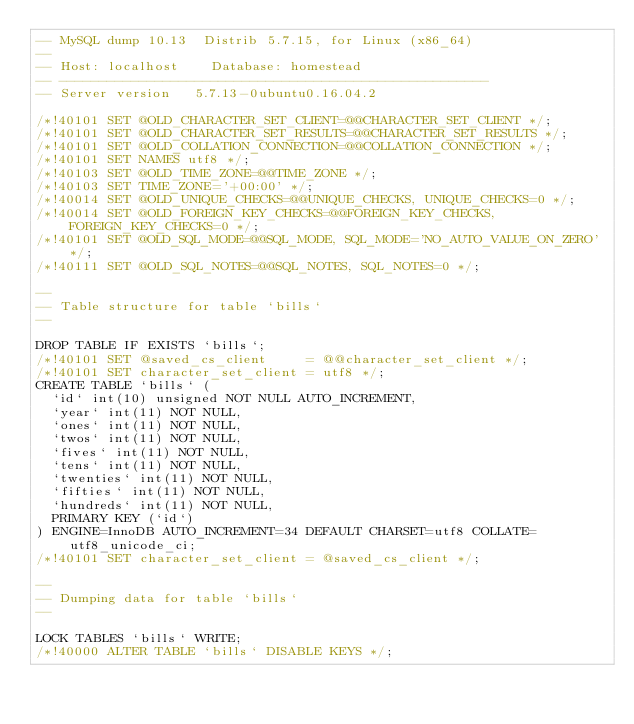Convert code to text. <code><loc_0><loc_0><loc_500><loc_500><_SQL_>-- MySQL dump 10.13  Distrib 5.7.15, for Linux (x86_64)
--
-- Host: localhost    Database: homestead
-- ------------------------------------------------------
-- Server version	5.7.13-0ubuntu0.16.04.2

/*!40101 SET @OLD_CHARACTER_SET_CLIENT=@@CHARACTER_SET_CLIENT */;
/*!40101 SET @OLD_CHARACTER_SET_RESULTS=@@CHARACTER_SET_RESULTS */;
/*!40101 SET @OLD_COLLATION_CONNECTION=@@COLLATION_CONNECTION */;
/*!40101 SET NAMES utf8 */;
/*!40103 SET @OLD_TIME_ZONE=@@TIME_ZONE */;
/*!40103 SET TIME_ZONE='+00:00' */;
/*!40014 SET @OLD_UNIQUE_CHECKS=@@UNIQUE_CHECKS, UNIQUE_CHECKS=0 */;
/*!40014 SET @OLD_FOREIGN_KEY_CHECKS=@@FOREIGN_KEY_CHECKS, FOREIGN_KEY_CHECKS=0 */;
/*!40101 SET @OLD_SQL_MODE=@@SQL_MODE, SQL_MODE='NO_AUTO_VALUE_ON_ZERO' */;
/*!40111 SET @OLD_SQL_NOTES=@@SQL_NOTES, SQL_NOTES=0 */;

--
-- Table structure for table `bills`
--

DROP TABLE IF EXISTS `bills`;
/*!40101 SET @saved_cs_client     = @@character_set_client */;
/*!40101 SET character_set_client = utf8 */;
CREATE TABLE `bills` (
  `id` int(10) unsigned NOT NULL AUTO_INCREMENT,
  `year` int(11) NOT NULL,
  `ones` int(11) NOT NULL,
  `twos` int(11) NOT NULL,
  `fives` int(11) NOT NULL,
  `tens` int(11) NOT NULL,
  `twenties` int(11) NOT NULL,
  `fifties` int(11) NOT NULL,
  `hundreds` int(11) NOT NULL,
  PRIMARY KEY (`id`)
) ENGINE=InnoDB AUTO_INCREMENT=34 DEFAULT CHARSET=utf8 COLLATE=utf8_unicode_ci;
/*!40101 SET character_set_client = @saved_cs_client */;

--
-- Dumping data for table `bills`
--

LOCK TABLES `bills` WRITE;
/*!40000 ALTER TABLE `bills` DISABLE KEYS */;</code> 